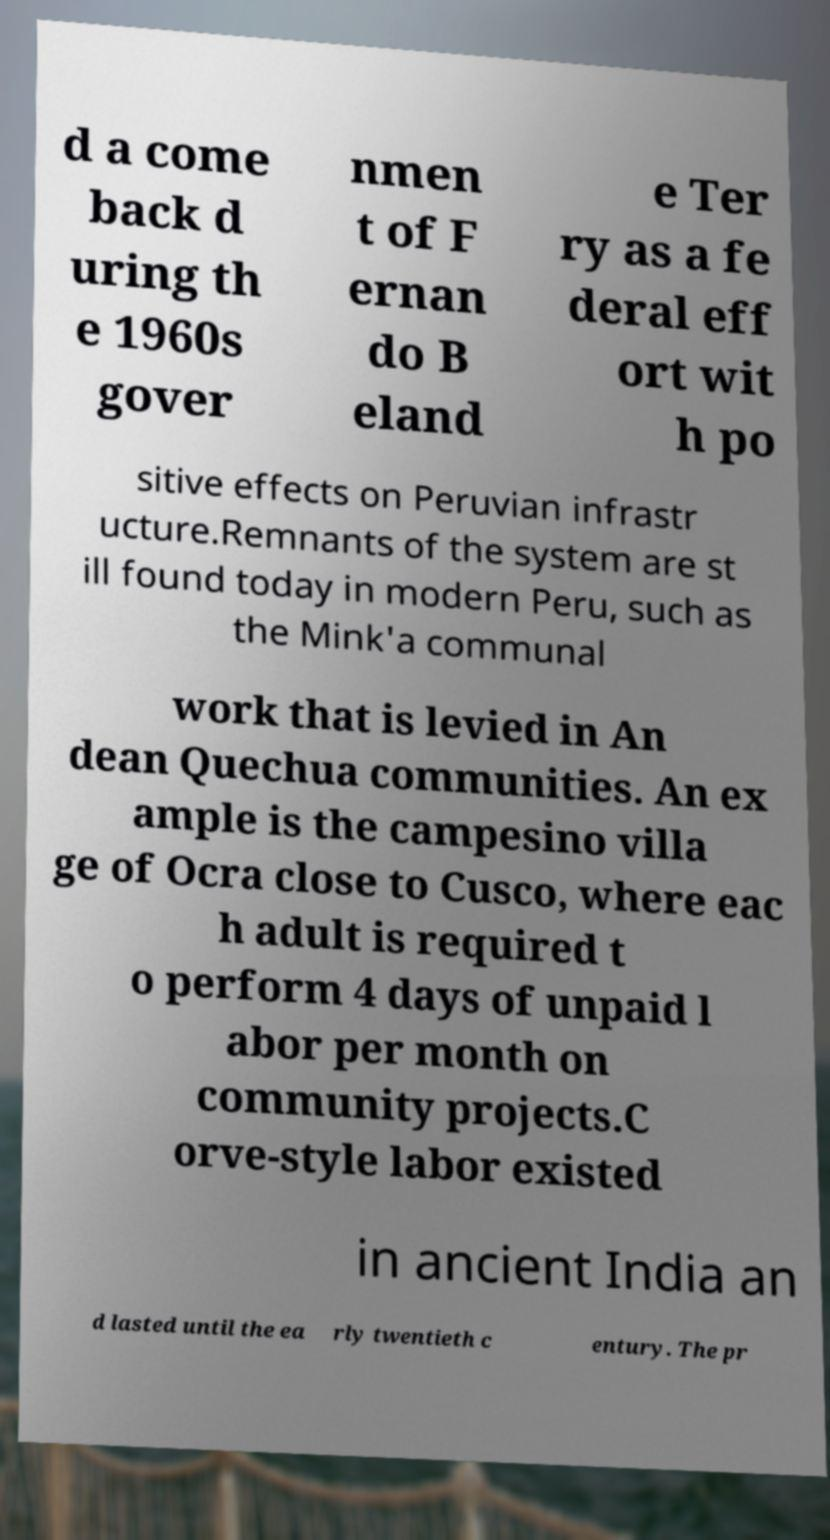Please read and relay the text visible in this image. What does it say? d a come back d uring th e 1960s gover nmen t of F ernan do B eland e Ter ry as a fe deral eff ort wit h po sitive effects on Peruvian infrastr ucture.Remnants of the system are st ill found today in modern Peru, such as the Mink'a communal work that is levied in An dean Quechua communities. An ex ample is the campesino villa ge of Ocra close to Cusco, where eac h adult is required t o perform 4 days of unpaid l abor per month on community projects.C orve-style labor existed in ancient India an d lasted until the ea rly twentieth c entury. The pr 